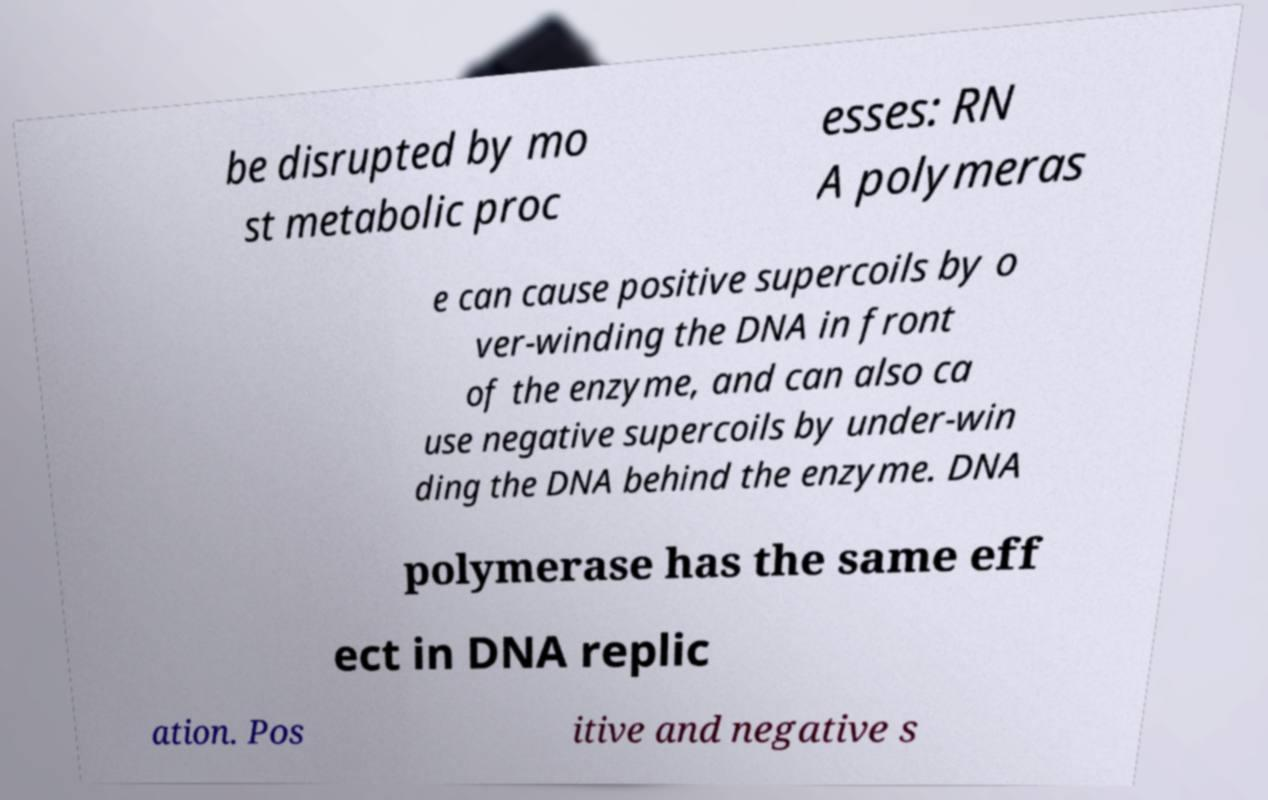Please identify and transcribe the text found in this image. be disrupted by mo st metabolic proc esses: RN A polymeras e can cause positive supercoils by o ver-winding the DNA in front of the enzyme, and can also ca use negative supercoils by under-win ding the DNA behind the enzyme. DNA polymerase has the same eff ect in DNA replic ation. Pos itive and negative s 